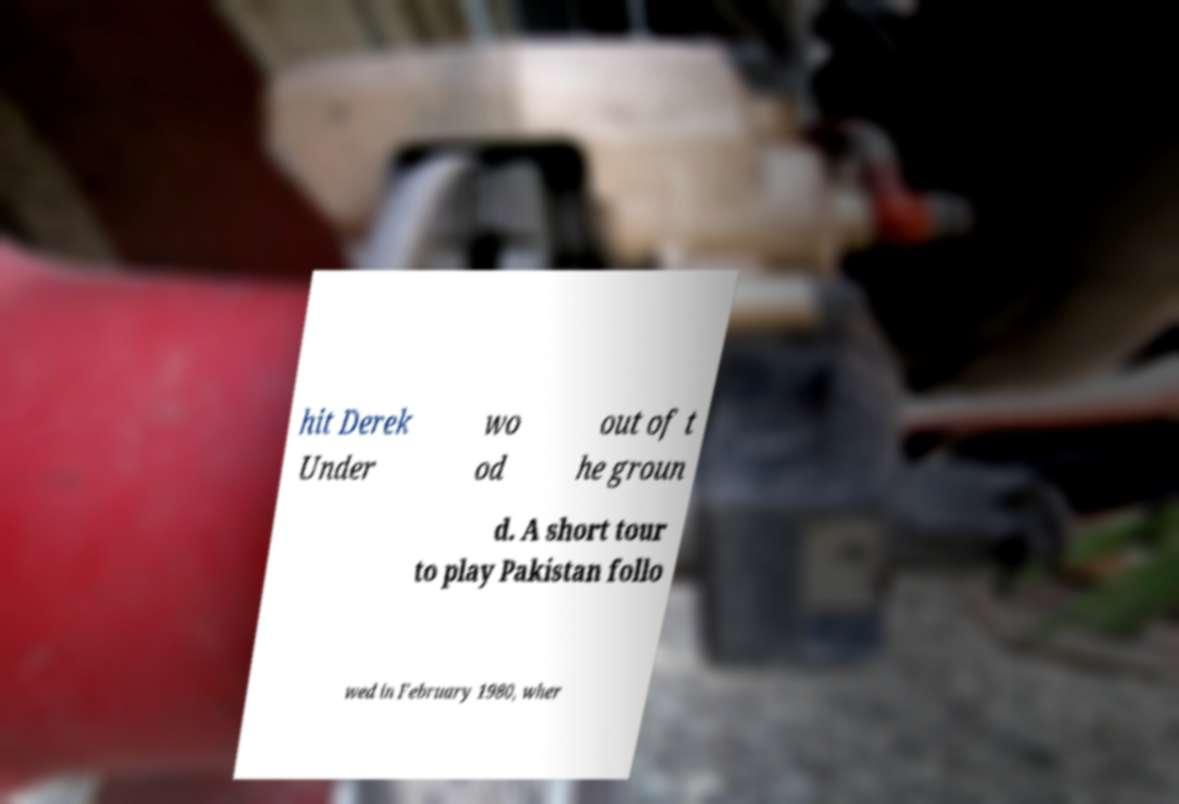For documentation purposes, I need the text within this image transcribed. Could you provide that? hit Derek Under wo od out of t he groun d. A short tour to play Pakistan follo wed in February 1980, wher 